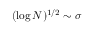Convert formula to latex. <formula><loc_0><loc_0><loc_500><loc_500>( \log N ) ^ { 1 / 2 } \sim \sigma</formula> 